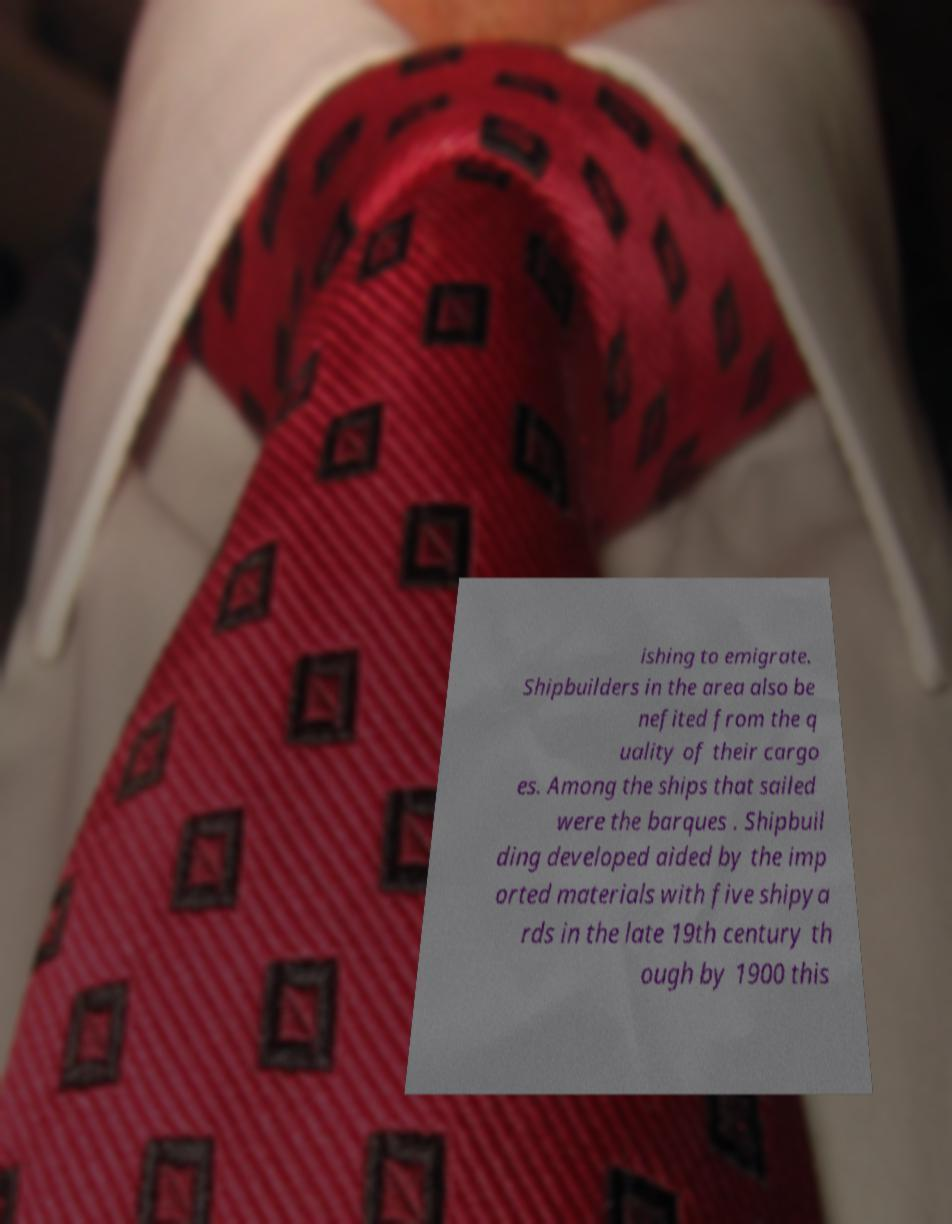Please identify and transcribe the text found in this image. ishing to emigrate. Shipbuilders in the area also be nefited from the q uality of their cargo es. Among the ships that sailed were the barques . Shipbuil ding developed aided by the imp orted materials with five shipya rds in the late 19th century th ough by 1900 this 